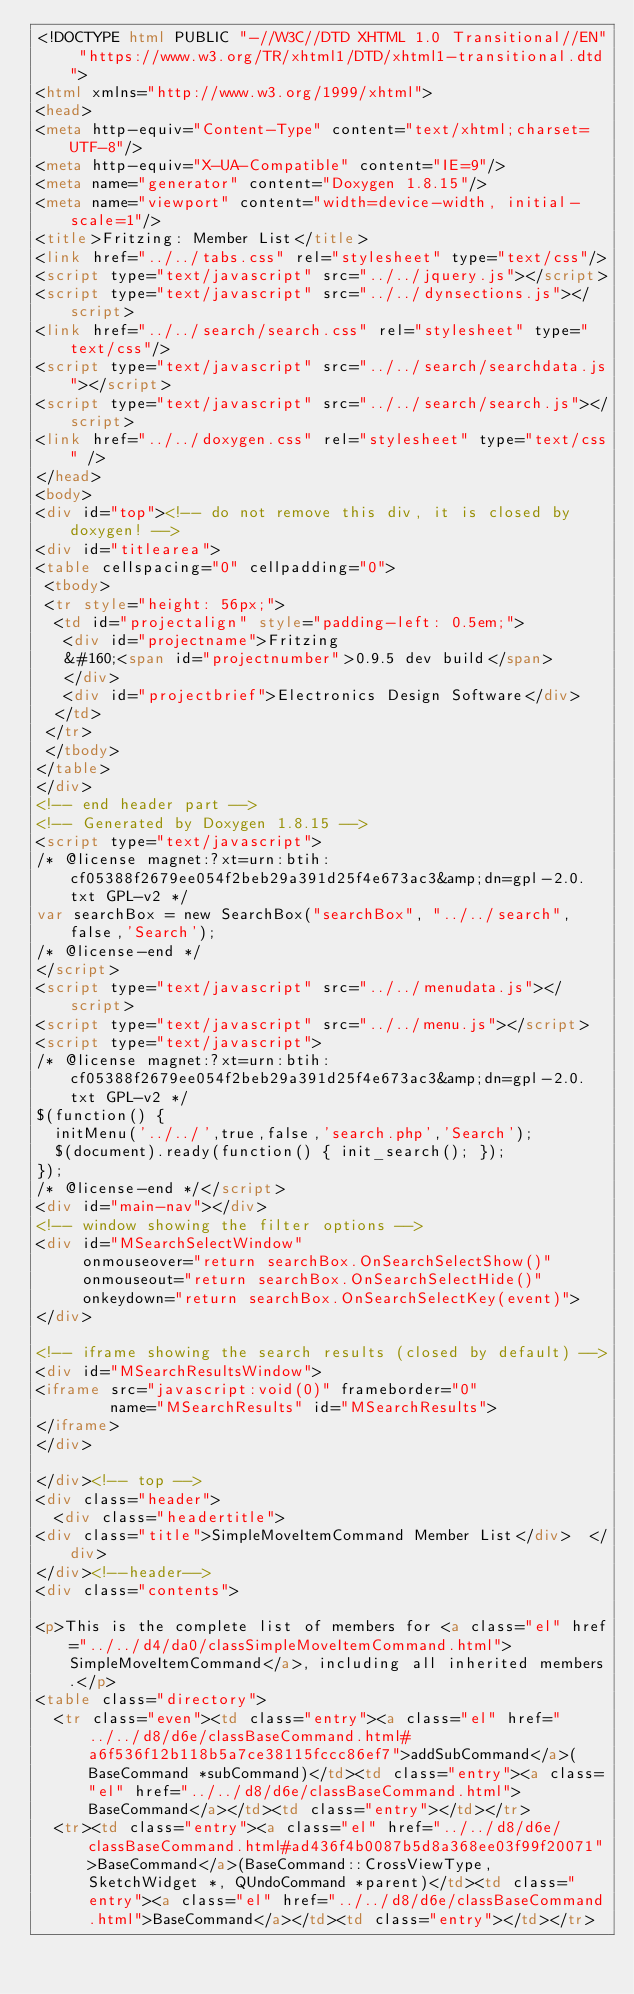Convert code to text. <code><loc_0><loc_0><loc_500><loc_500><_HTML_><!DOCTYPE html PUBLIC "-//W3C//DTD XHTML 1.0 Transitional//EN" "https://www.w3.org/TR/xhtml1/DTD/xhtml1-transitional.dtd">
<html xmlns="http://www.w3.org/1999/xhtml">
<head>
<meta http-equiv="Content-Type" content="text/xhtml;charset=UTF-8"/>
<meta http-equiv="X-UA-Compatible" content="IE=9"/>
<meta name="generator" content="Doxygen 1.8.15"/>
<meta name="viewport" content="width=device-width, initial-scale=1"/>
<title>Fritzing: Member List</title>
<link href="../../tabs.css" rel="stylesheet" type="text/css"/>
<script type="text/javascript" src="../../jquery.js"></script>
<script type="text/javascript" src="../../dynsections.js"></script>
<link href="../../search/search.css" rel="stylesheet" type="text/css"/>
<script type="text/javascript" src="../../search/searchdata.js"></script>
<script type="text/javascript" src="../../search/search.js"></script>
<link href="../../doxygen.css" rel="stylesheet" type="text/css" />
</head>
<body>
<div id="top"><!-- do not remove this div, it is closed by doxygen! -->
<div id="titlearea">
<table cellspacing="0" cellpadding="0">
 <tbody>
 <tr style="height: 56px;">
  <td id="projectalign" style="padding-left: 0.5em;">
   <div id="projectname">Fritzing
   &#160;<span id="projectnumber">0.9.5 dev build</span>
   </div>
   <div id="projectbrief">Electronics Design Software</div>
  </td>
 </tr>
 </tbody>
</table>
</div>
<!-- end header part -->
<!-- Generated by Doxygen 1.8.15 -->
<script type="text/javascript">
/* @license magnet:?xt=urn:btih:cf05388f2679ee054f2beb29a391d25f4e673ac3&amp;dn=gpl-2.0.txt GPL-v2 */
var searchBox = new SearchBox("searchBox", "../../search",false,'Search');
/* @license-end */
</script>
<script type="text/javascript" src="../../menudata.js"></script>
<script type="text/javascript" src="../../menu.js"></script>
<script type="text/javascript">
/* @license magnet:?xt=urn:btih:cf05388f2679ee054f2beb29a391d25f4e673ac3&amp;dn=gpl-2.0.txt GPL-v2 */
$(function() {
  initMenu('../../',true,false,'search.php','Search');
  $(document).ready(function() { init_search(); });
});
/* @license-end */</script>
<div id="main-nav"></div>
<!-- window showing the filter options -->
<div id="MSearchSelectWindow"
     onmouseover="return searchBox.OnSearchSelectShow()"
     onmouseout="return searchBox.OnSearchSelectHide()"
     onkeydown="return searchBox.OnSearchSelectKey(event)">
</div>

<!-- iframe showing the search results (closed by default) -->
<div id="MSearchResultsWindow">
<iframe src="javascript:void(0)" frameborder="0" 
        name="MSearchResults" id="MSearchResults">
</iframe>
</div>

</div><!-- top -->
<div class="header">
  <div class="headertitle">
<div class="title">SimpleMoveItemCommand Member List</div>  </div>
</div><!--header-->
<div class="contents">

<p>This is the complete list of members for <a class="el" href="../../d4/da0/classSimpleMoveItemCommand.html">SimpleMoveItemCommand</a>, including all inherited members.</p>
<table class="directory">
  <tr class="even"><td class="entry"><a class="el" href="../../d8/d6e/classBaseCommand.html#a6f536f12b118b5a7ce38115fccc86ef7">addSubCommand</a>(BaseCommand *subCommand)</td><td class="entry"><a class="el" href="../../d8/d6e/classBaseCommand.html">BaseCommand</a></td><td class="entry"></td></tr>
  <tr><td class="entry"><a class="el" href="../../d8/d6e/classBaseCommand.html#ad436f4b0087b5d8a368ee03f99f20071">BaseCommand</a>(BaseCommand::CrossViewType, SketchWidget *, QUndoCommand *parent)</td><td class="entry"><a class="el" href="../../d8/d6e/classBaseCommand.html">BaseCommand</a></td><td class="entry"></td></tr></code> 